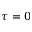<formula> <loc_0><loc_0><loc_500><loc_500>\tau = 0</formula> 